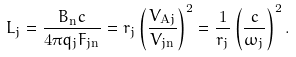<formula> <loc_0><loc_0><loc_500><loc_500>L _ { j } = \frac { B _ { \mathrm n } c } { 4 \pi q _ { j } F _ { j \mathrm n } } = r _ { j } \left ( \frac { V _ { \mathrm A j } } { V _ { j \mathrm n } } \right ) ^ { 2 } = \frac { 1 } { r _ { j } } \left ( \frac { c } { \omega _ { j } } \right ) ^ { 2 } .</formula> 